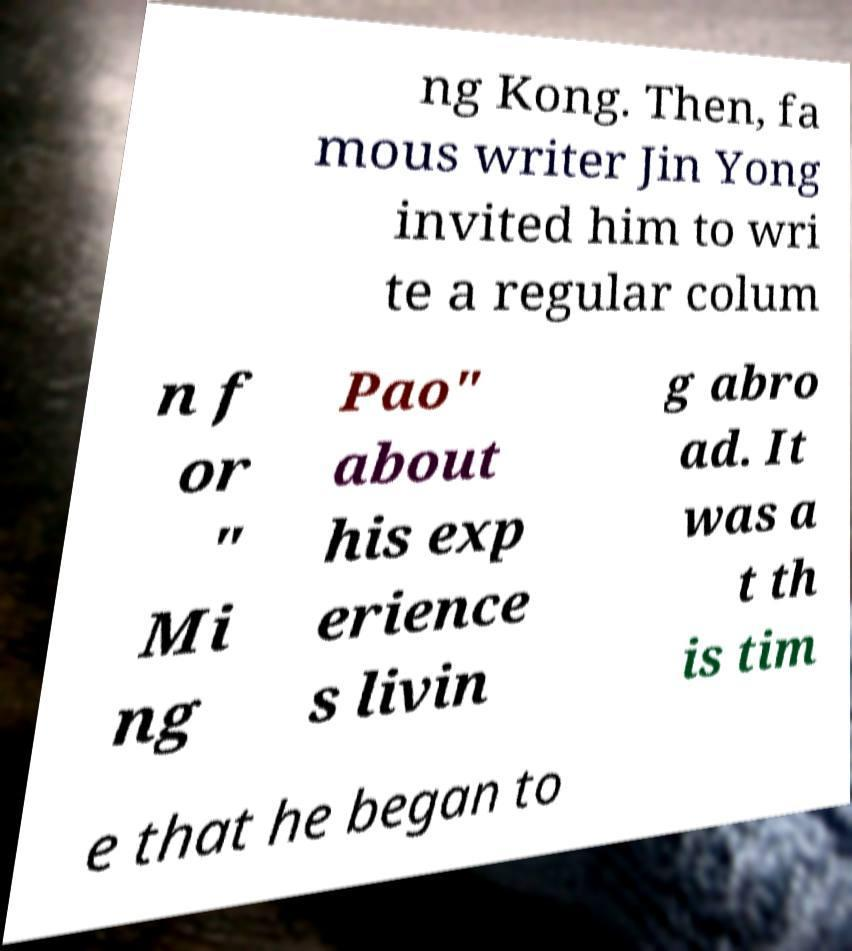Can you read and provide the text displayed in the image?This photo seems to have some interesting text. Can you extract and type it out for me? ng Kong. Then, fa mous writer Jin Yong invited him to wri te a regular colum n f or " Mi ng Pao" about his exp erience s livin g abro ad. It was a t th is tim e that he began to 